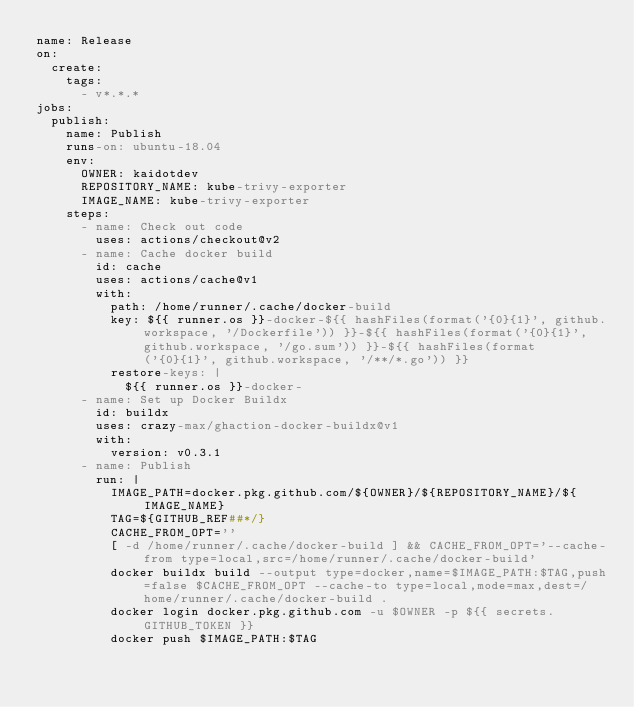<code> <loc_0><loc_0><loc_500><loc_500><_YAML_>name: Release
on:
  create:
    tags:
      - v*.*.*
jobs:
  publish:
    name: Publish
    runs-on: ubuntu-18.04
    env:
      OWNER: kaidotdev
      REPOSITORY_NAME: kube-trivy-exporter
      IMAGE_NAME: kube-trivy-exporter
    steps:
      - name: Check out code
        uses: actions/checkout@v2
      - name: Cache docker build
        id: cache
        uses: actions/cache@v1
        with:
          path: /home/runner/.cache/docker-build
          key: ${{ runner.os }}-docker-${{ hashFiles(format('{0}{1}', github.workspace, '/Dockerfile')) }}-${{ hashFiles(format('{0}{1}', github.workspace, '/go.sum')) }}-${{ hashFiles(format('{0}{1}', github.workspace, '/**/*.go')) }}
          restore-keys: |
            ${{ runner.os }}-docker-
      - name: Set up Docker Buildx
        id: buildx
        uses: crazy-max/ghaction-docker-buildx@v1
        with:
          version: v0.3.1
      - name: Publish
        run: |
          IMAGE_PATH=docker.pkg.github.com/${OWNER}/${REPOSITORY_NAME}/${IMAGE_NAME}
          TAG=${GITHUB_REF##*/}
          CACHE_FROM_OPT=''
          [ -d /home/runner/.cache/docker-build ] && CACHE_FROM_OPT='--cache-from type=local,src=/home/runner/.cache/docker-build'
          docker buildx build --output type=docker,name=$IMAGE_PATH:$TAG,push=false $CACHE_FROM_OPT --cache-to type=local,mode=max,dest=/home/runner/.cache/docker-build .
          docker login docker.pkg.github.com -u $OWNER -p ${{ secrets.GITHUB_TOKEN }}
          docker push $IMAGE_PATH:$TAG
</code> 